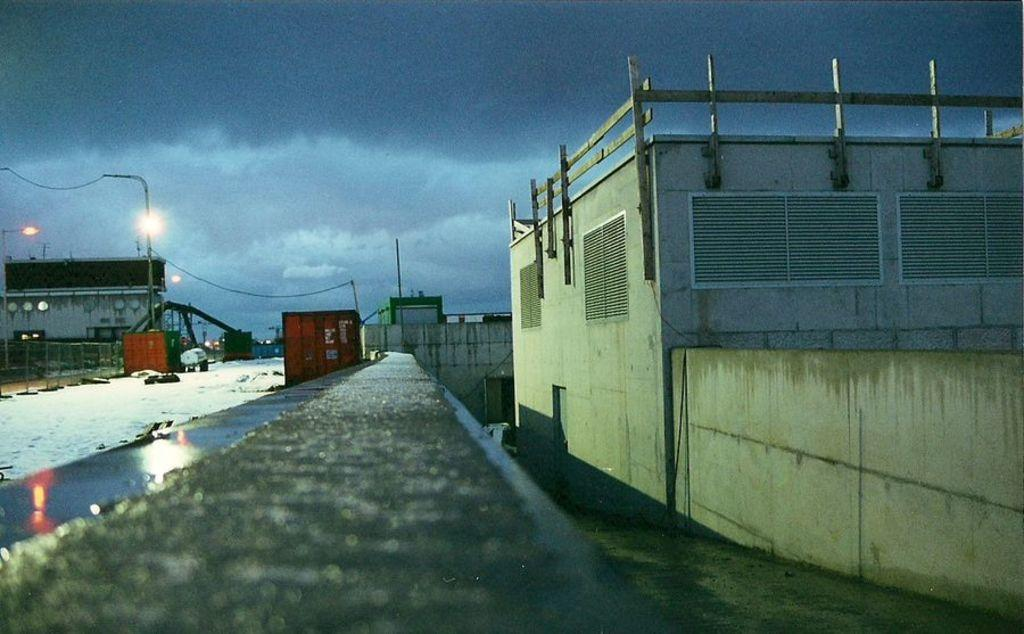What type of structures can be seen in the image? There are buildings in the image. What is covering the ground in the image? The ground is covered with snow. What can be found on the footpath in the image? There are street light poles on the footpath. Can you see a carriage being pulled by horses in the image? No, there is no carriage or horses present in the image. What type of ring can be seen on the street light poles in the image? There are no rings on the street light poles in the image. 